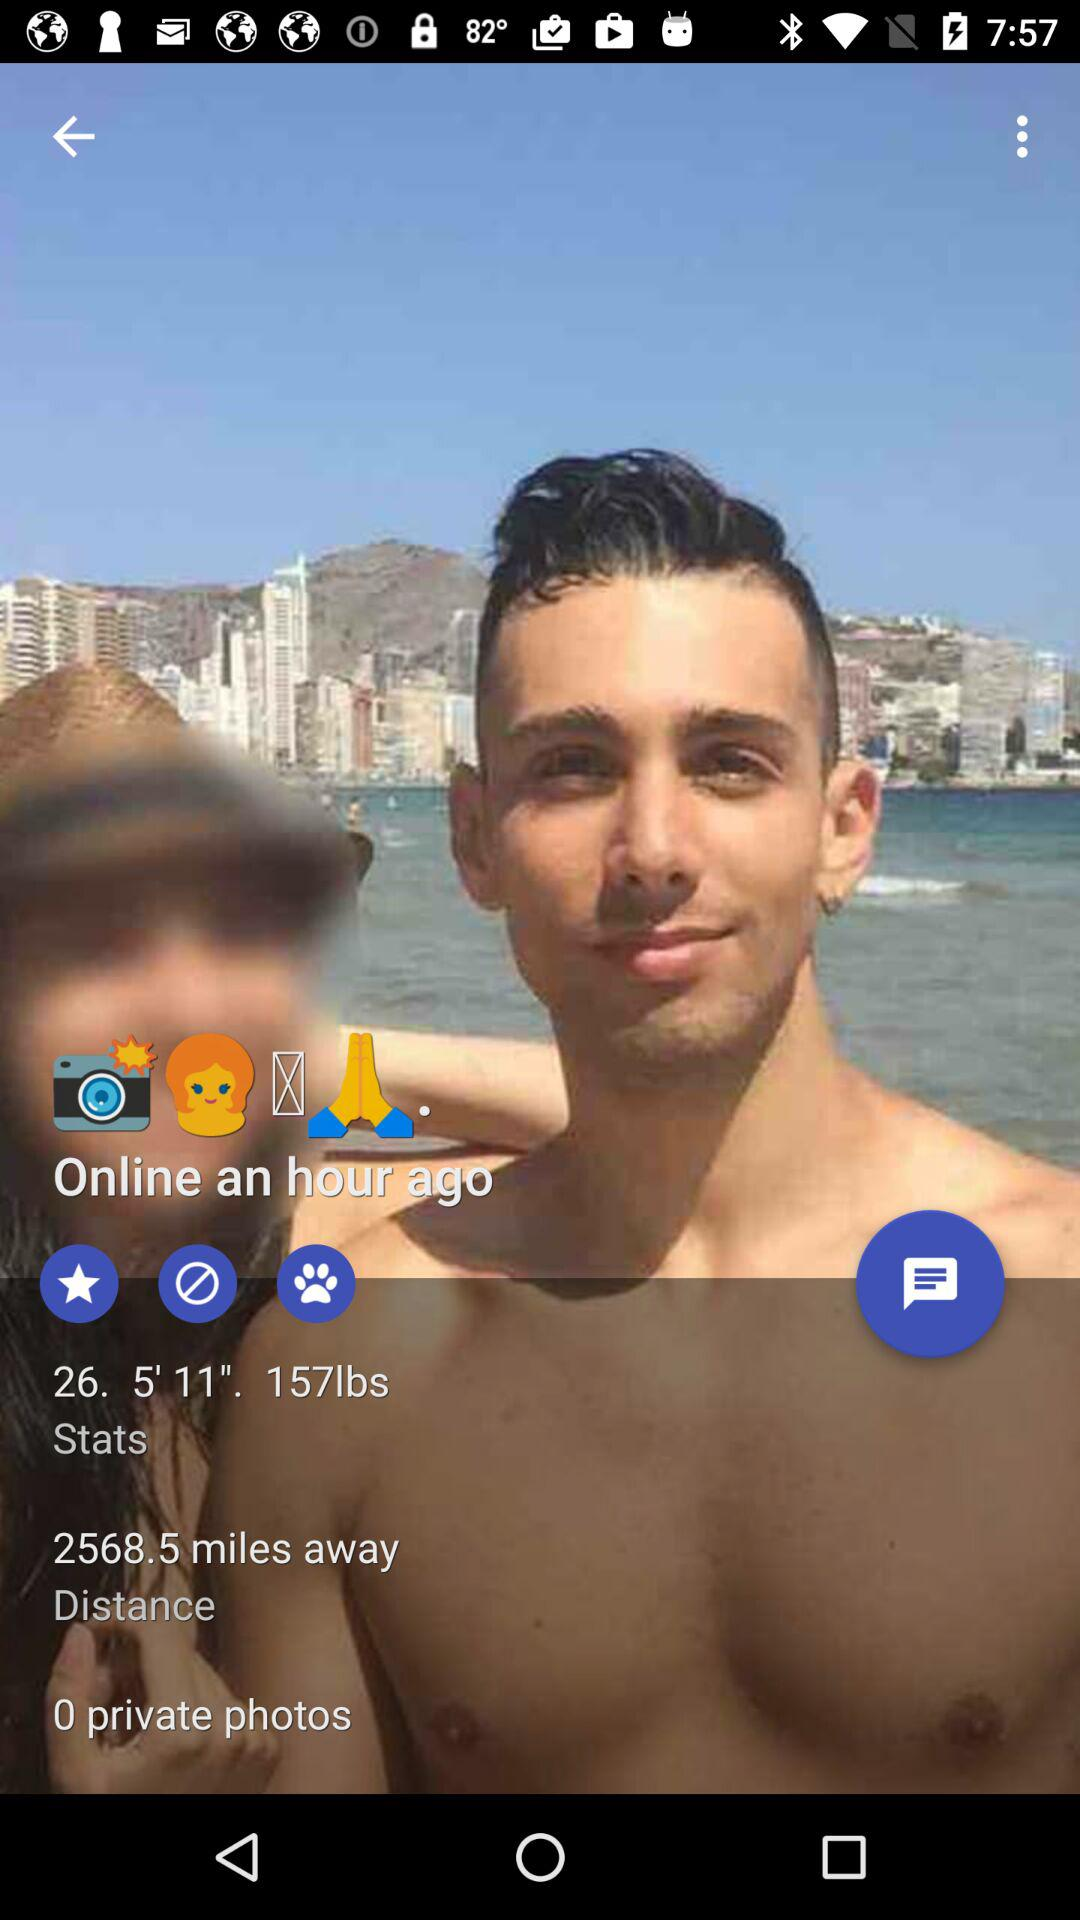What is the age of the user? The age of the user is 26. 